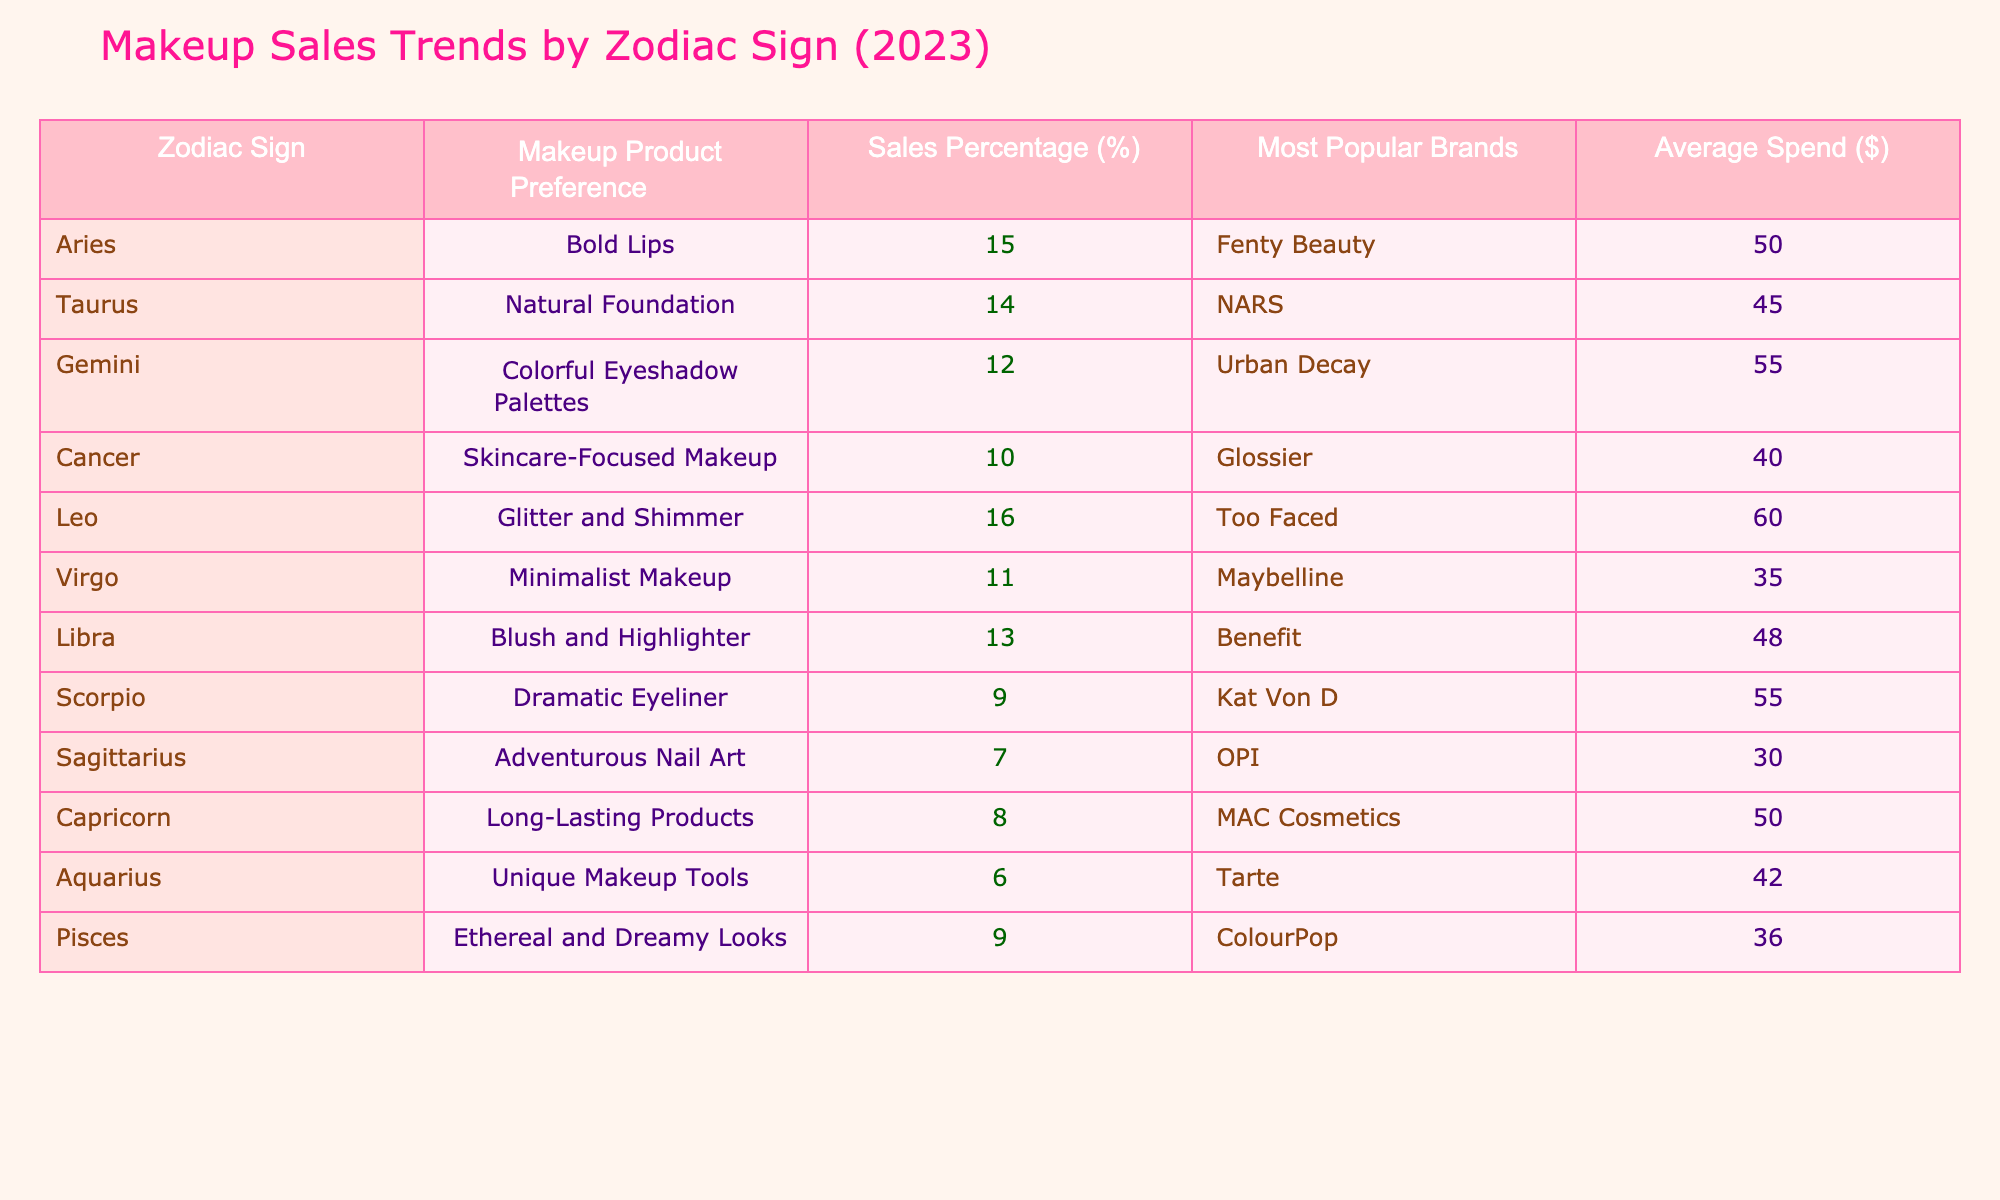What is the sales percentage for Leo? According to the table, the sales percentage for Leo is listed under the 'Sales Percentage (%)' column next to the 'Leo' row, which states 16%.
Answer: 16% Which zodiac sign prefers natural foundation? By looking at the 'Makeup Product Preference' column, Taurus is the zodiac sign that prefers natural foundation, as indicated in the corresponding row.
Answer: Taurus What is the average spend for Aries and Taurus combined? To find the average spend, first, we add the average spends for Aries ($50) and Taurus ($45), which equals $95. Then, we divide that by 2, since there are two signs: 95/2 = 47.5.
Answer: 47.5 Is Scorpio's makeup product preference more popular than that of Pisces? By comparing the 'Sales Percentage (%)' for Scorpio (9%) and Pisces (9%), we can see that they are equal, so the answer is no.
Answer: No What is the most popular brand for a Virgo? Referring to the most popular brands column, for Virgo, the most popular brand is Maybelline as stated in the corresponding row.
Answer: Maybelline Which makeup product preference has the highest sales percentage? By scanning through the 'Sales Percentage (%)' column, we find that Leo with glitter and shimmer has the highest sales percentage at 16%.
Answer: Glitter and shimmer What is the total sales percentage of all signs that prefer dramatic makeup (Scorpio and Leo)? We first identify the sales percentages for Scorpio (9%) and Leo (16%). Adding these gives us 9 + 16 = 25%.
Answer: 25% Do Libras spend more than Cancers on average? The average spend for Libras is $48 and for Cancers, it is $40. Since $48 is greater than $40, the answer is yes.
Answer: Yes Which zodiac sign has the lowest sales percentage? Checking the 'Sales Percentage (%)' column, Sagittarius has the lowest sales percentage at 7%.
Answer: Sagittarius 